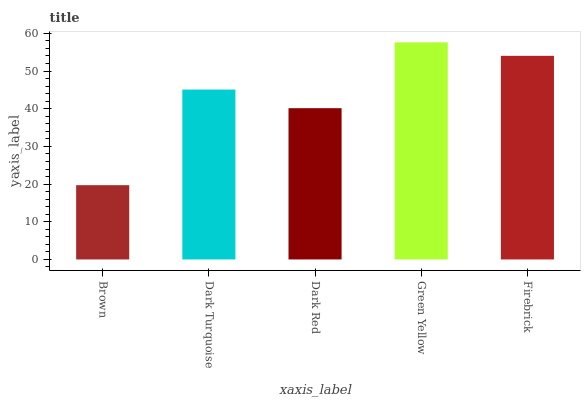Is Brown the minimum?
Answer yes or no. Yes. Is Green Yellow the maximum?
Answer yes or no. Yes. Is Dark Turquoise the minimum?
Answer yes or no. No. Is Dark Turquoise the maximum?
Answer yes or no. No. Is Dark Turquoise greater than Brown?
Answer yes or no. Yes. Is Brown less than Dark Turquoise?
Answer yes or no. Yes. Is Brown greater than Dark Turquoise?
Answer yes or no. No. Is Dark Turquoise less than Brown?
Answer yes or no. No. Is Dark Turquoise the high median?
Answer yes or no. Yes. Is Dark Turquoise the low median?
Answer yes or no. Yes. Is Brown the high median?
Answer yes or no. No. Is Green Yellow the low median?
Answer yes or no. No. 